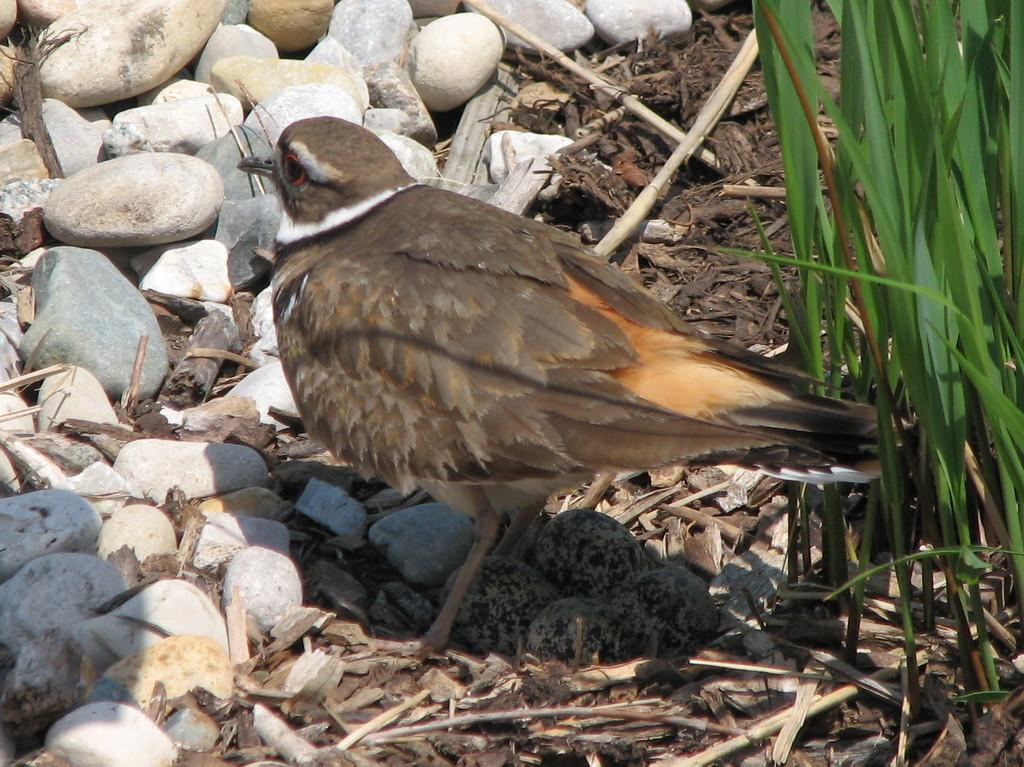How many birds are visible in the image? There is one bird in the image. What is located near the bird on the ground? There are four bird eggs on the ground. What type of natural elements can be seen in the image? There are stones and dried sticks on the ground. What type of vegetation is present on the right side of the image? There is grass on the right side of the image. What type of pocket can be seen on the bird's face in the image? There is no pocket or face present on the bird in the image. Can you describe the cat that is sitting next to the bird in the image? There is no cat present in the image; it only features a bird, bird eggs, stones, dried sticks, and grass. 